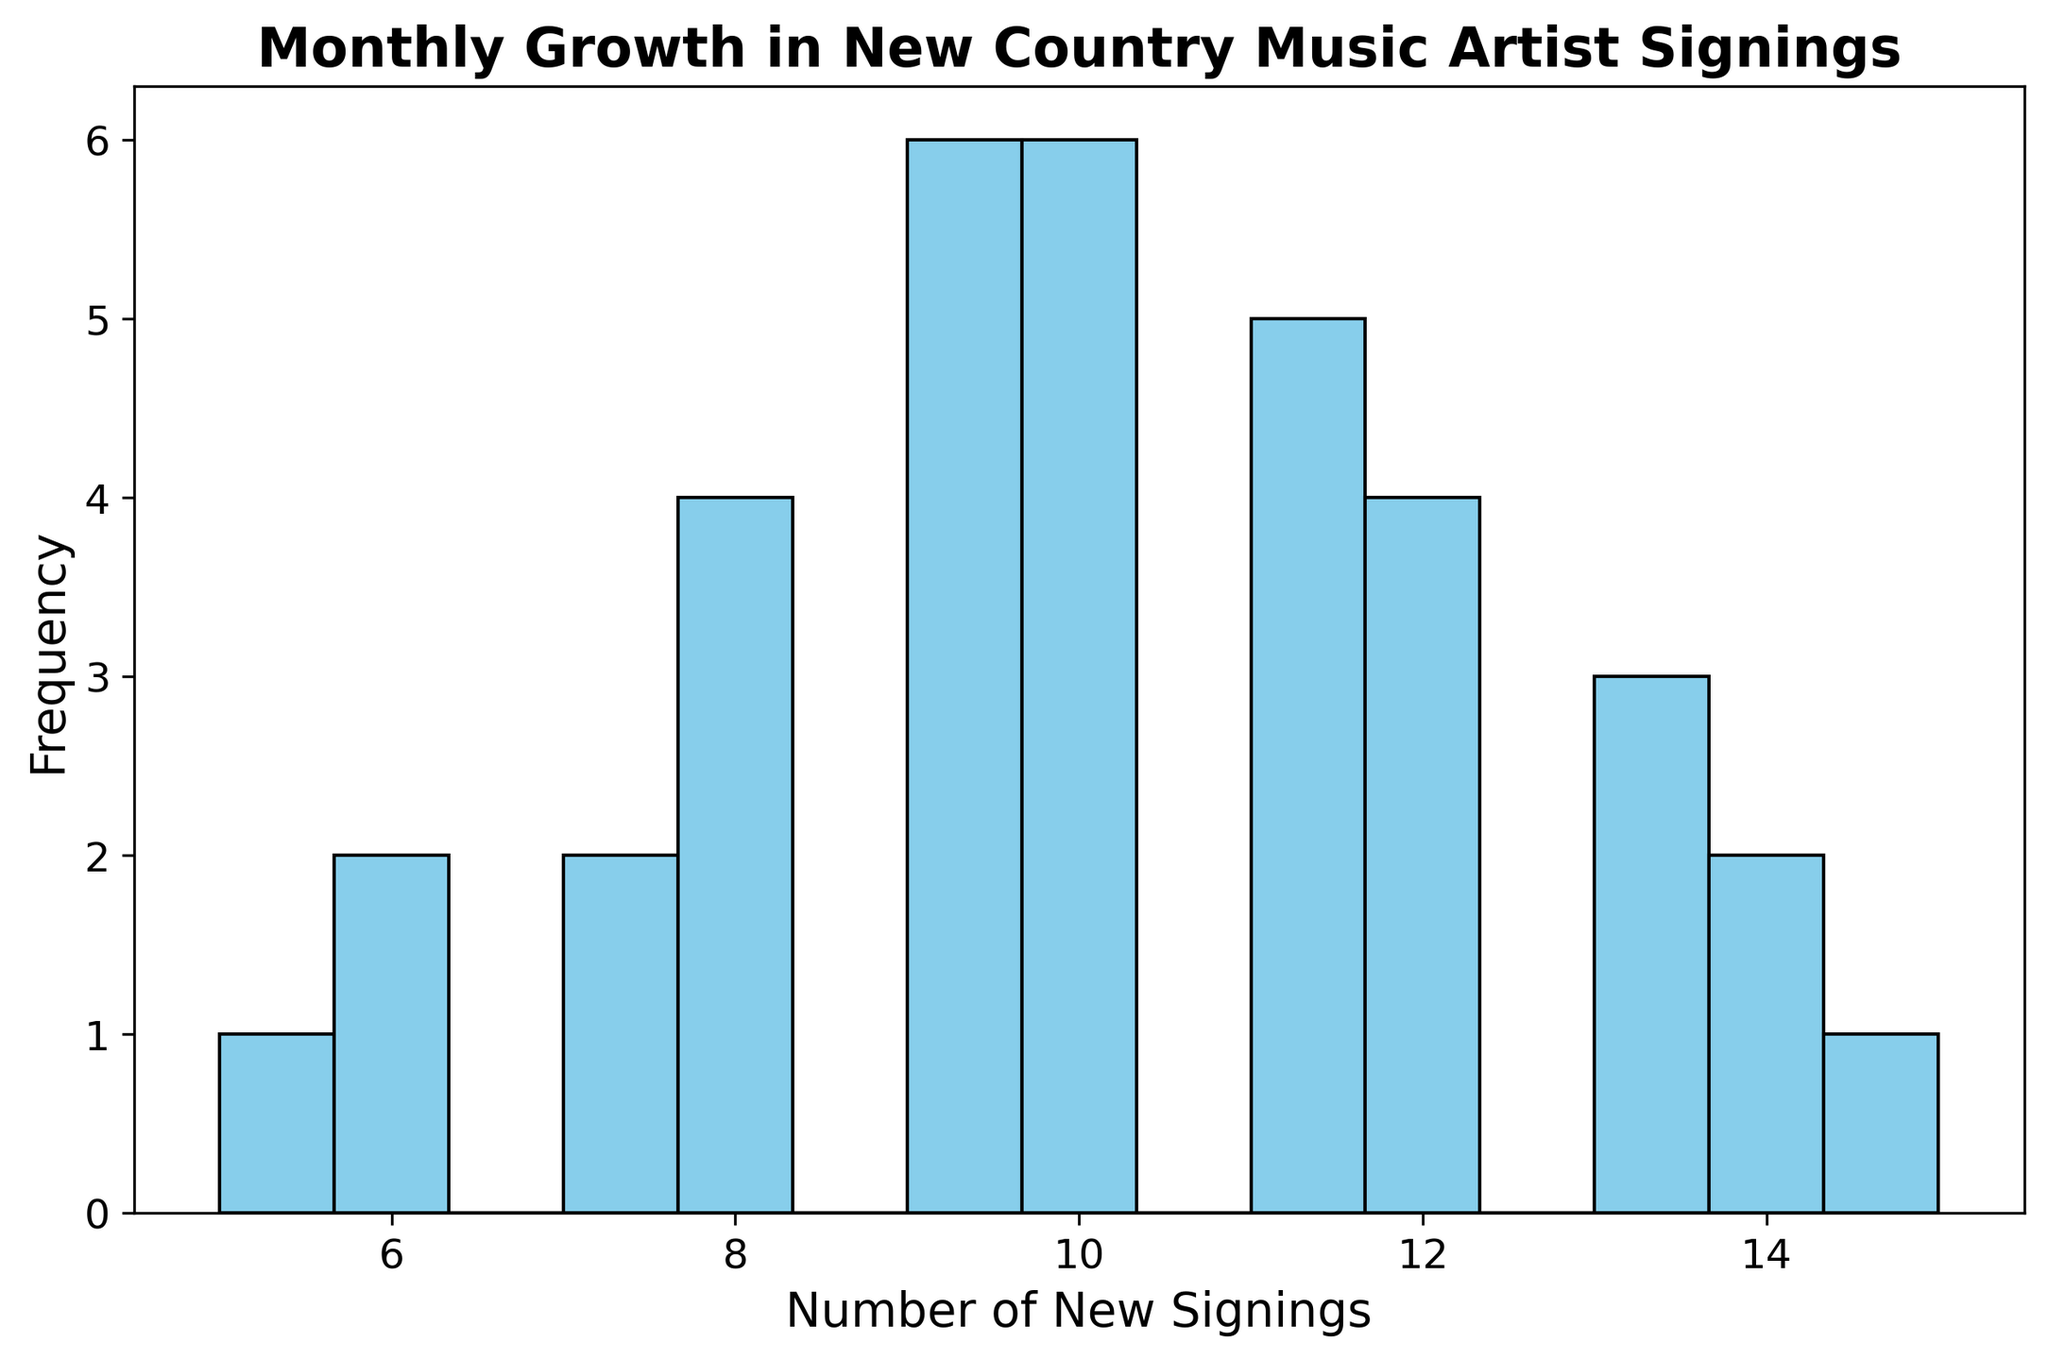What is the most common number of new signings in a month? We determine this by looking at the bar heights in the histogram to identify which number of new signings occurs most frequently. The highest bar indicates the most frequent value.
Answer: 10 Which month seen an increasing trend in artist signings? Observing the placement and frequency of values along the x-axis, we determine if any specific monthly data points increase over time. Over the two-year period, months like July and September show a general trend of higher new signings.
Answer: July and September What is the range of new signings across the months? To find the range, identify the minimum and maximum values on the x-axis, which represent the lowest and highest counts of new signings. Calculate the difference between these two values.
Answer: 10 What is the total number of months with 12 new signings? Locate the bar corresponding to the value "12" on the x-axis and determine its height, which indicates the frequency of months that saw 12 new signings.
Answer: 3 Which month frequency shows a larger count: 8 or 10 new signings? Compare the heights of bars corresponding to the values "8" and "10" along the x-axis to see which has a taller bar, indicating a larger count.
Answer: 10 new signings How many months had new signings of at least 11? Identify the bars that correspond to values of 11 and above, then sum the frequencies (heights) of these bars.
Answer: 12 What is the average number of new signings per month? To compute this, sum up all new signings values from the dataset and divide by the total number of months (36). First, sum up (sum of signings) = 294. Then, divide by 36 months.
Answer: 9 Compare the number of months with 9 new signings to the number of months with 13 new signings. Which is higher? Identify and compare the heights of the bars corresponding to 9 and 13 signings. Determine which has the greater height.
Answer: 9 new signings What's the frequency of months with single digits (less than 10) new signings? Sum the frequencies of bars representing any values from 5 to 9. Count the months corresponding to values 5, 6, 7, 8, and 9 along the x-axis.
Answer: 20 Which value of new signings appears least frequently? Identify the shortest bar in the histogram that corresponds to the value with the minimum frequency.
Answer: 5 